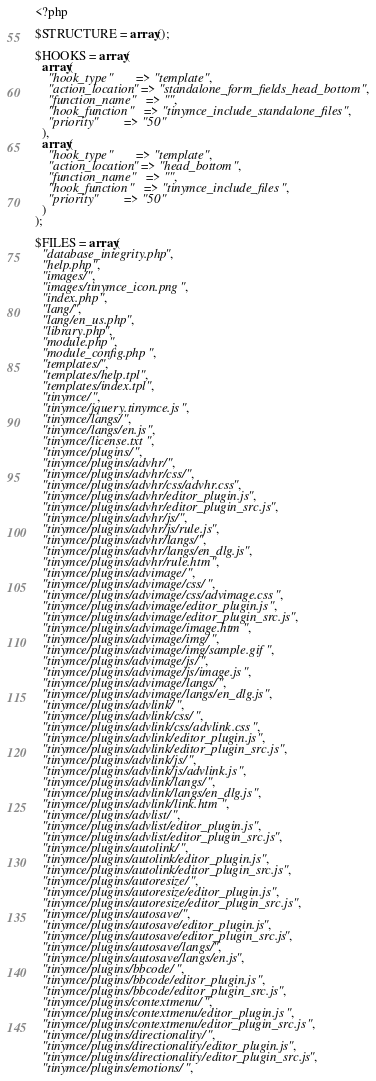Convert code to text. <code><loc_0><loc_0><loc_500><loc_500><_PHP_><?php

$STRUCTURE = array();

$HOOKS = array(
  array(
    "hook_type"       => "template",
    "action_location" => "standalone_form_fields_head_bottom",
    "function_name"   => "",
    "hook_function"   => "tinymce_include_standalone_files",
    "priority"        => "50"
  ),
  array(
    "hook_type"       => "template",
    "action_location" => "head_bottom",
    "function_name"   => "",
    "hook_function"   => "tinymce_include_files",
    "priority"        => "50"
  )
);

$FILES = array(
  "database_integrity.php",
  "help.php",
  "images/",
  "images/tinymce_icon.png",
  "index.php",
  "lang/",
  "lang/en_us.php",
  "library.php",
  "module.php",
  "module_config.php",
  "templates/",
  "templates/help.tpl",
  "templates/index.tpl",
  "tinymce/",
  "tinymce/jquery.tinymce.js",
  "tinymce/langs/",
  "tinymce/langs/en.js",
  "tinymce/license.txt",
  "tinymce/plugins/",
  "tinymce/plugins/advhr/",
  "tinymce/plugins/advhr/css/",
  "tinymce/plugins/advhr/css/advhr.css",
  "tinymce/plugins/advhr/editor_plugin.js",
  "tinymce/plugins/advhr/editor_plugin_src.js",
  "tinymce/plugins/advhr/js/",
  "tinymce/plugins/advhr/js/rule.js",
  "tinymce/plugins/advhr/langs/",
  "tinymce/plugins/advhr/langs/en_dlg.js",
  "tinymce/plugins/advhr/rule.htm",
  "tinymce/plugins/advimage/",
  "tinymce/plugins/advimage/css/",
  "tinymce/plugins/advimage/css/advimage.css",
  "tinymce/plugins/advimage/editor_plugin.js",
  "tinymce/plugins/advimage/editor_plugin_src.js",
  "tinymce/plugins/advimage/image.htm",
  "tinymce/plugins/advimage/img/",
  "tinymce/plugins/advimage/img/sample.gif",
  "tinymce/plugins/advimage/js/",
  "tinymce/plugins/advimage/js/image.js",
  "tinymce/plugins/advimage/langs/",
  "tinymce/plugins/advimage/langs/en_dlg.js",
  "tinymce/plugins/advlink/",
  "tinymce/plugins/advlink/css/",
  "tinymce/plugins/advlink/css/advlink.css",
  "tinymce/plugins/advlink/editor_plugin.js",
  "tinymce/plugins/advlink/editor_plugin_src.js",
  "tinymce/plugins/advlink/js/",
  "tinymce/plugins/advlink/js/advlink.js",
  "tinymce/plugins/advlink/langs/",
  "tinymce/plugins/advlink/langs/en_dlg.js",
  "tinymce/plugins/advlink/link.htm",
  "tinymce/plugins/advlist/",
  "tinymce/plugins/advlist/editor_plugin.js",
  "tinymce/plugins/advlist/editor_plugin_src.js",
  "tinymce/plugins/autolink/",
  "tinymce/plugins/autolink/editor_plugin.js",
  "tinymce/plugins/autolink/editor_plugin_src.js",
  "tinymce/plugins/autoresize/",
  "tinymce/plugins/autoresize/editor_plugin.js",
  "tinymce/plugins/autoresize/editor_plugin_src.js",
  "tinymce/plugins/autosave/",
  "tinymce/plugins/autosave/editor_plugin.js",
  "tinymce/plugins/autosave/editor_plugin_src.js",
  "tinymce/plugins/autosave/langs/",
  "tinymce/plugins/autosave/langs/en.js",
  "tinymce/plugins/bbcode/",
  "tinymce/plugins/bbcode/editor_plugin.js",
  "tinymce/plugins/bbcode/editor_plugin_src.js",
  "tinymce/plugins/contextmenu/",
  "tinymce/plugins/contextmenu/editor_plugin.js",
  "tinymce/plugins/contextmenu/editor_plugin_src.js",
  "tinymce/plugins/directionality/",
  "tinymce/plugins/directionality/editor_plugin.js",
  "tinymce/plugins/directionality/editor_plugin_src.js",
  "tinymce/plugins/emotions/",</code> 